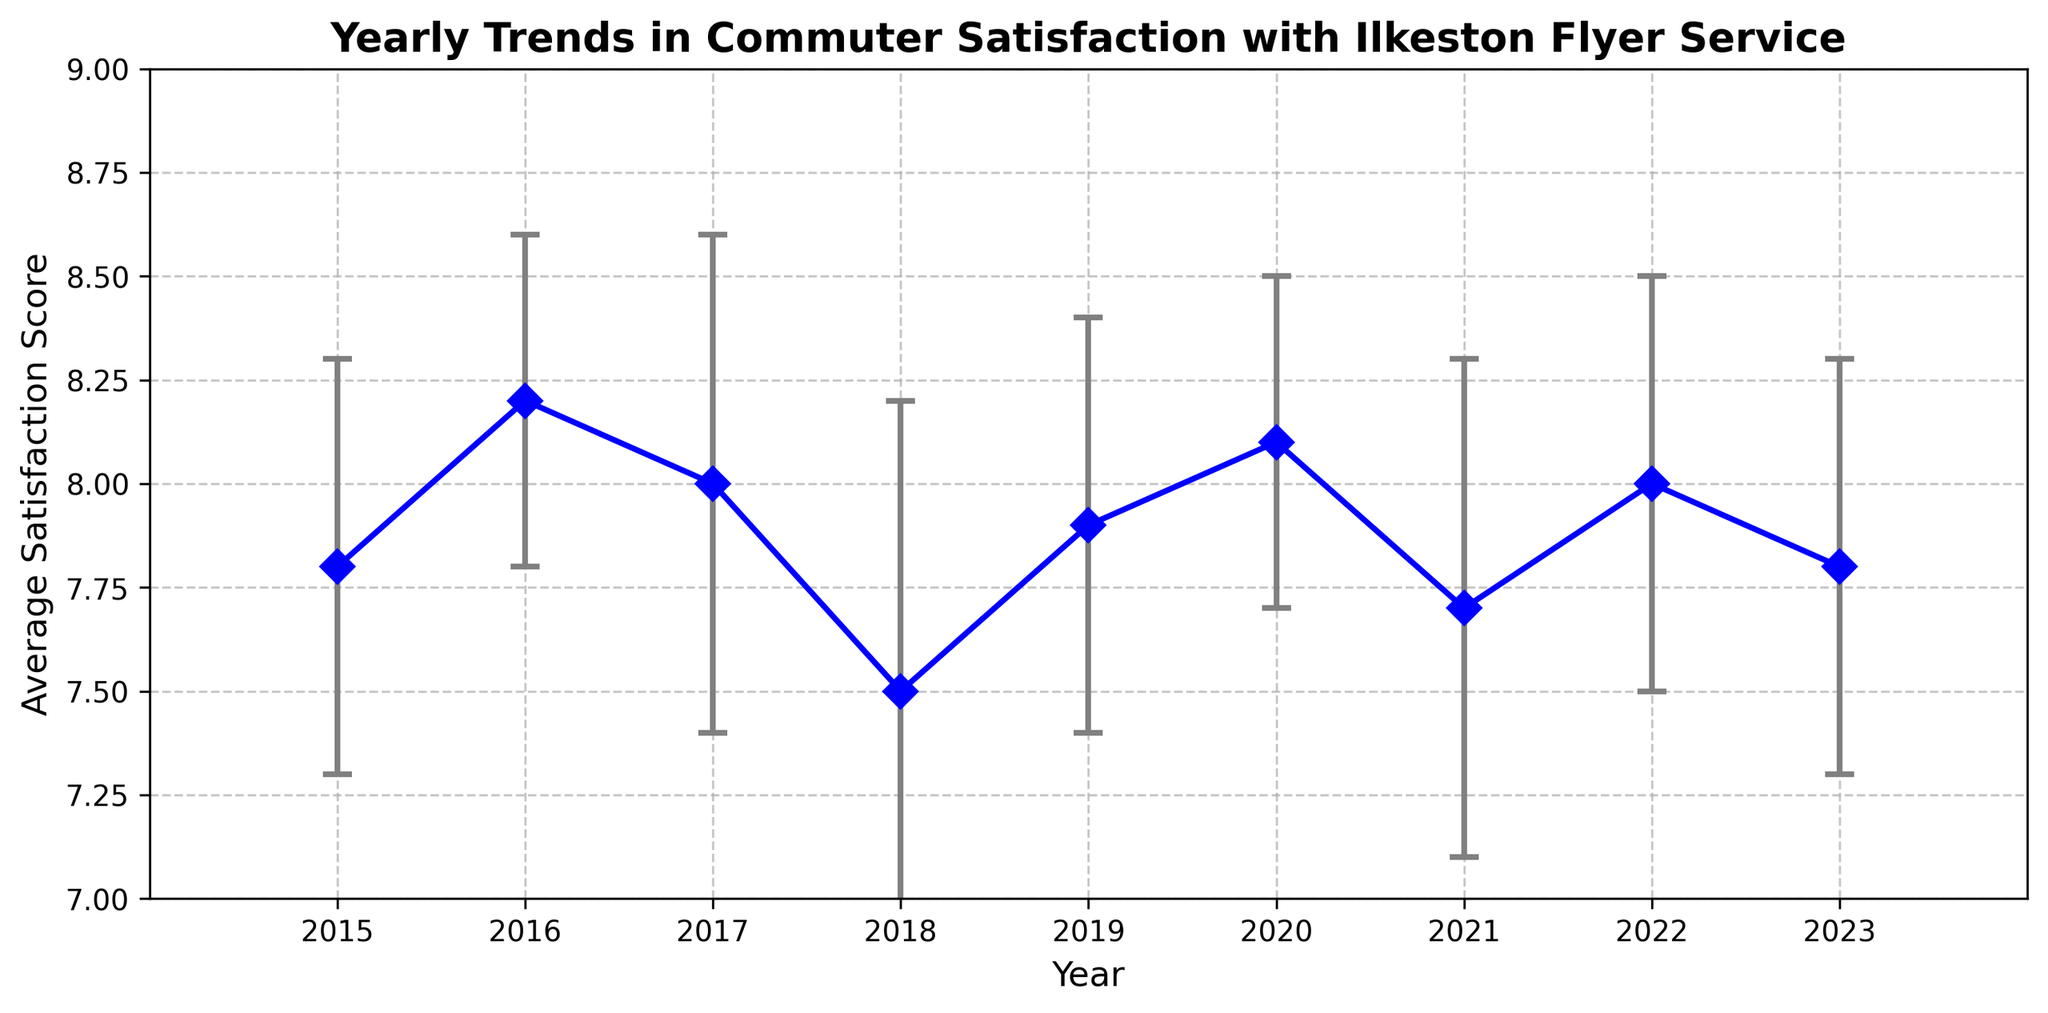What's the average commuter satisfaction score between 2015 and 2023? To find the average satisfaction score, sum up all the scores from 2015 to 2023 and then divide by the total number of years: (7.8 + 8.2 + 8.0 + 7.5 + 7.9 + 8.1 + 7.7 + 8.0 + 7.8) / 9 = 7.88
Answer: 7.88 Which year had the highest average commuter satisfaction score? Looking at the figure, identify the year with the highest data point. The year 2016 has the highest satisfaction score of 8.2.
Answer: 2016 Compare the average commuter satisfaction scores in 2018 and 2020. Which year was higher? Inspect the figure to see the satisfaction scores for 2018 and 2020. The score for 2018 is 7.5, while for 2020 it is 8.1. 2020 had a higher satisfaction score.
Answer: 2020 What was the difference in average commuter satisfaction between 2018 and 2020? Subtract the satisfaction score of 2018 from that of 2020: 8.1 - 7.5 = 0.6
Answer: 0.6 Which year had the largest standard deviation in commuter satisfaction scores? Identify the year with the longest error bar. 2018, with a standard deviation of 0.7, has the largest error bar.
Answer: 2018 How does the average commuter satisfaction for 2023 compare to 2015? Compare the data points for 2023 and 2015 in the figure. Both years have the same average satisfaction score of 7.8.
Answer: Equal What is the range of average satisfaction scores from 2015 to 2023? To find the range, subtract the smallest score from the largest score: 8.2 (highest in 2016) - 7.5 (lowest in 2018) = 0.7
Answer: 0.7 Visually, do most of the years have a satisfaction score above or below 7.9? By examining the satisfaction scores in the figure, most of the years have scores at or above 7.9: 2016, 2017, 2019, 2020, 2021, 2022, and 2023.
Answer: Above Between 2021 and 2022, how did the average satisfaction score change? Check the satisfaction scores for 2021 (7.7) and 2022 (8.0) and calculate the difference: 8.0 - 7.7 = 0.3. The score increased by 0.3.
Answer: Increased by 0.3 What is the general trend in commuter satisfaction from 2015 to 2023? Looking at the overall pattern in the figure, the satisfaction scores fluctuate but generally hover around a steady range without large swings.
Answer: Steady with fluctuations 